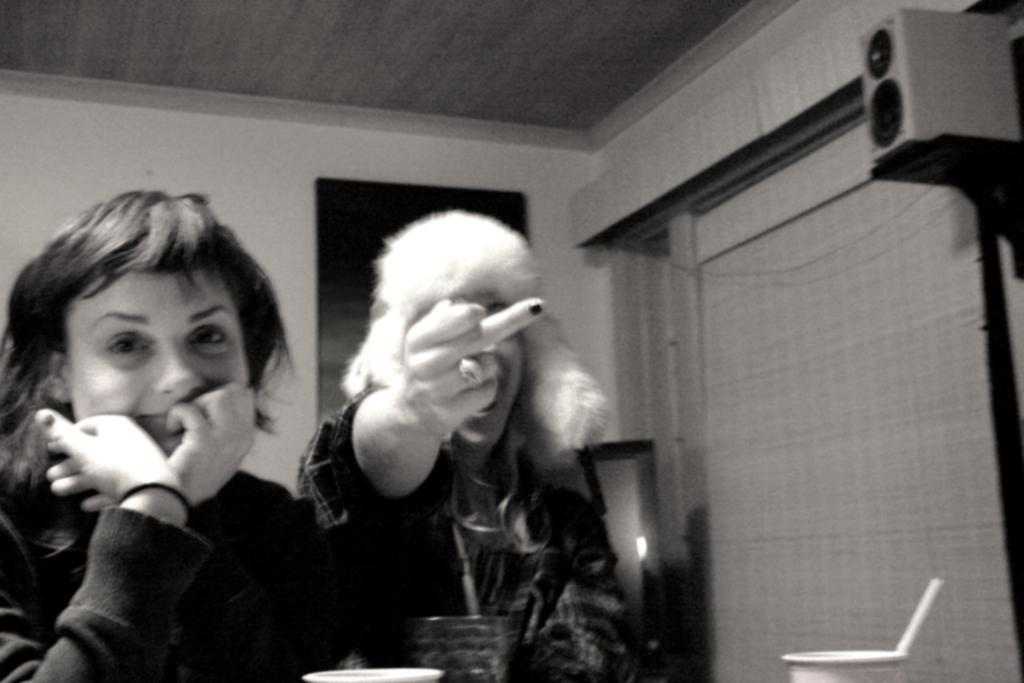What is the color scheme of the image? The image is black and white. How many people are in the image? There are two persons in the image. What object can be seen on the right side of the image? There is a speaker on the right side of the image. What is located at the bottom of the image? Glasses are present at the bottom of the image. Can you tell me how many threads are visible in the image? There are no threads present in the image. What type of road can be seen in the image? There is no road visible in the image. 